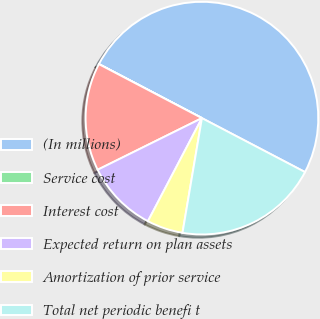<chart> <loc_0><loc_0><loc_500><loc_500><pie_chart><fcel>(In millions)<fcel>Service cost<fcel>Interest cost<fcel>Expected return on plan assets<fcel>Amortization of prior service<fcel>Total net periodic benefi t<nl><fcel>49.98%<fcel>0.01%<fcel>15.0%<fcel>10.0%<fcel>5.01%<fcel>20.0%<nl></chart> 